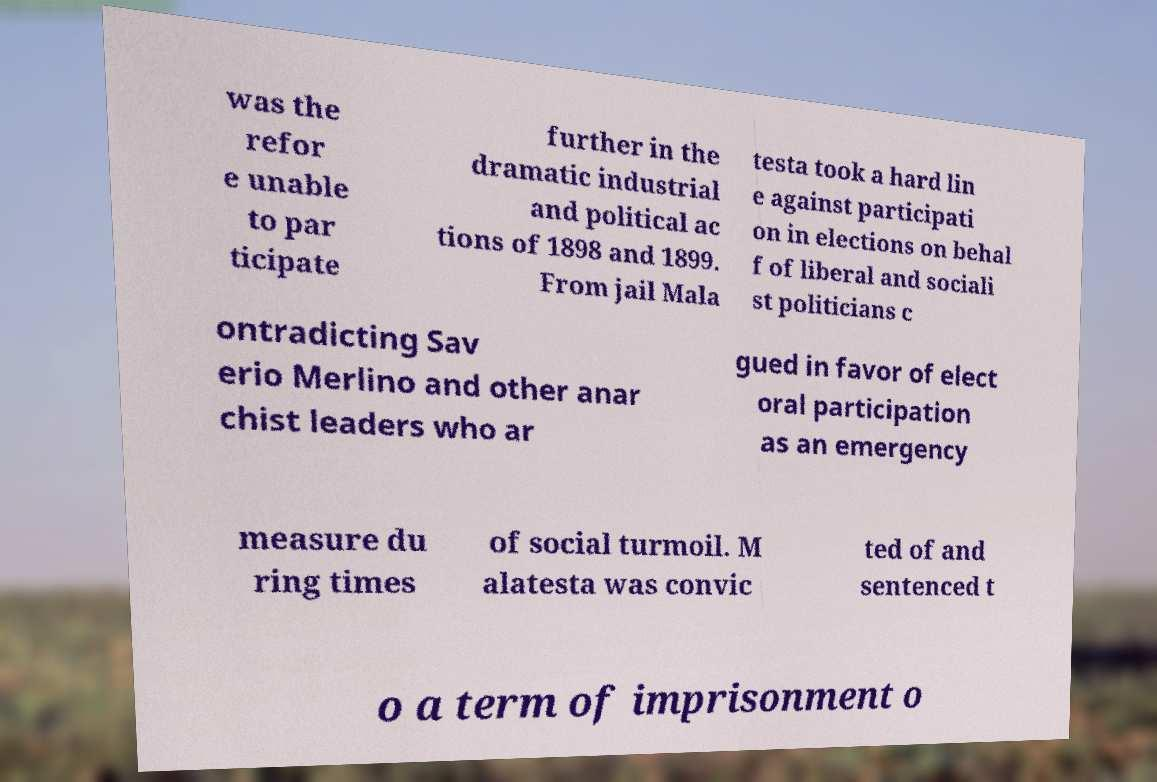Could you extract and type out the text from this image? was the refor e unable to par ticipate further in the dramatic industrial and political ac tions of 1898 and 1899. From jail Mala testa took a hard lin e against participati on in elections on behal f of liberal and sociali st politicians c ontradicting Sav erio Merlino and other anar chist leaders who ar gued in favor of elect oral participation as an emergency measure du ring times of social turmoil. M alatesta was convic ted of and sentenced t o a term of imprisonment o 